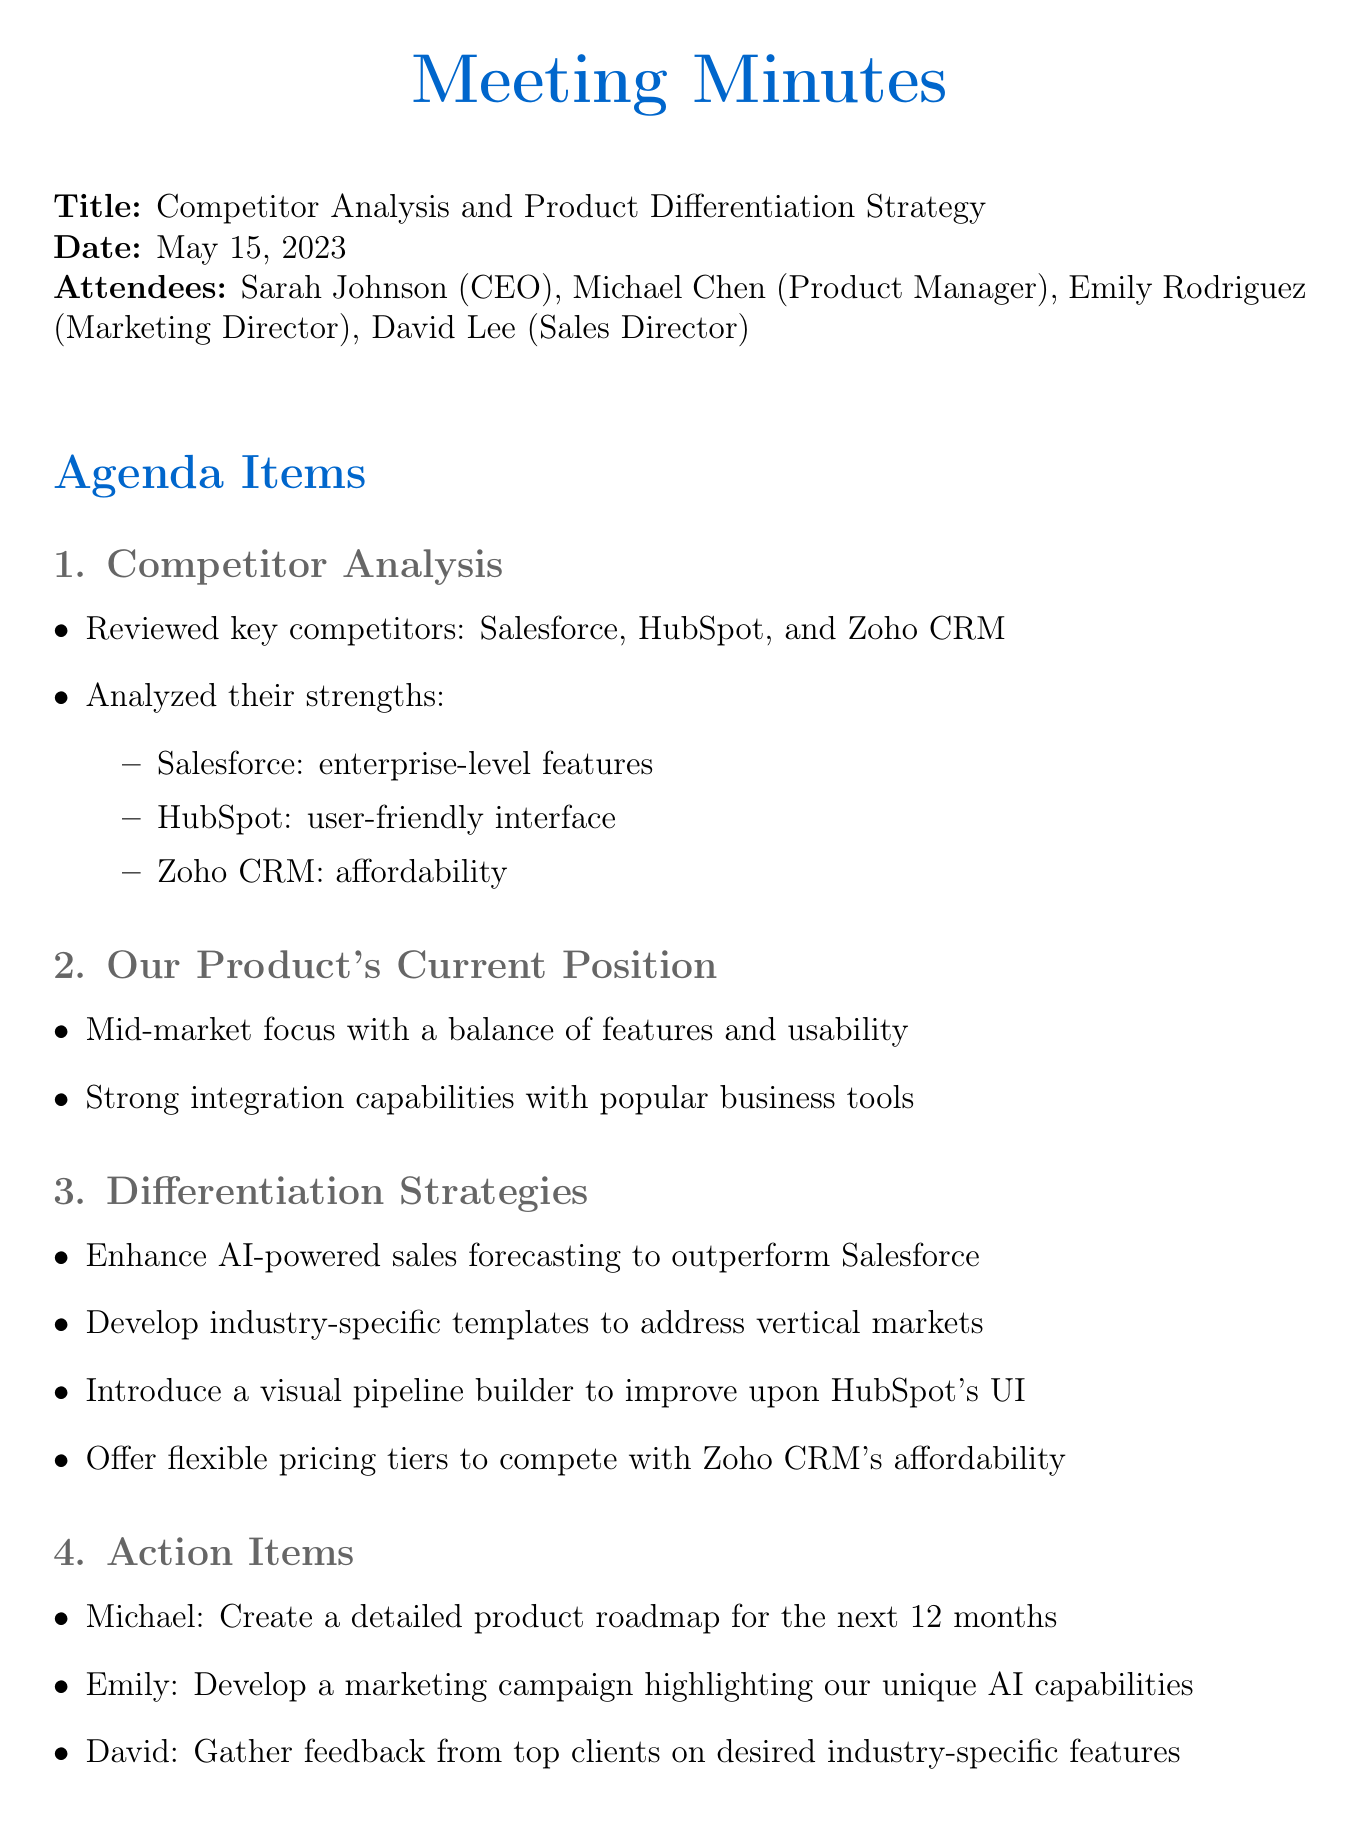What is the date of the meeting? The document states the meeting took place on May 15, 2023.
Answer: May 15, 2023 Who is the Product Manager? The document lists Michael Chen as the Product Manager in the attendees section.
Answer: Michael Chen What are the key competitors mentioned? The document lists Salesforce, HubSpot, and Zoho CRM as the key competitors discussed in the meeting.
Answer: Salesforce, HubSpot, Zoho CRM What is our product's main market focus? The document indicates that the product has a mid-market focus.
Answer: Mid-market What is one differentiation strategy proposed? The document outlines that one strategy is to enhance AI-powered sales forecasting.
Answer: Enhance AI-powered sales forecasting Who is responsible for creating the product roadmap? The meeting minutes specify that Michael is tasked with creating the detailed product roadmap.
Answer: Michael What was the CEO's stance on the differentiation strategies? The document mentions that the CEO expressed strong support for them.
Answer: Strong support What is an action item for the Marketing Director? The document states that Emily is to develop a marketing campaign highlighting unique AI capabilities.
Answer: Develop a marketing campaign What did the CEO emphasize in the closing remarks? The document notes that the CEO emphasized the importance of swift execution.
Answer: Swift execution 